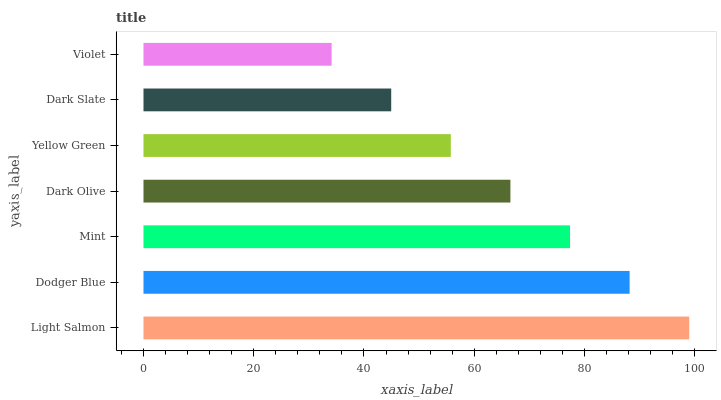Is Violet the minimum?
Answer yes or no. Yes. Is Light Salmon the maximum?
Answer yes or no. Yes. Is Dodger Blue the minimum?
Answer yes or no. No. Is Dodger Blue the maximum?
Answer yes or no. No. Is Light Salmon greater than Dodger Blue?
Answer yes or no. Yes. Is Dodger Blue less than Light Salmon?
Answer yes or no. Yes. Is Dodger Blue greater than Light Salmon?
Answer yes or no. No. Is Light Salmon less than Dodger Blue?
Answer yes or no. No. Is Dark Olive the high median?
Answer yes or no. Yes. Is Dark Olive the low median?
Answer yes or no. Yes. Is Dark Slate the high median?
Answer yes or no. No. Is Mint the low median?
Answer yes or no. No. 